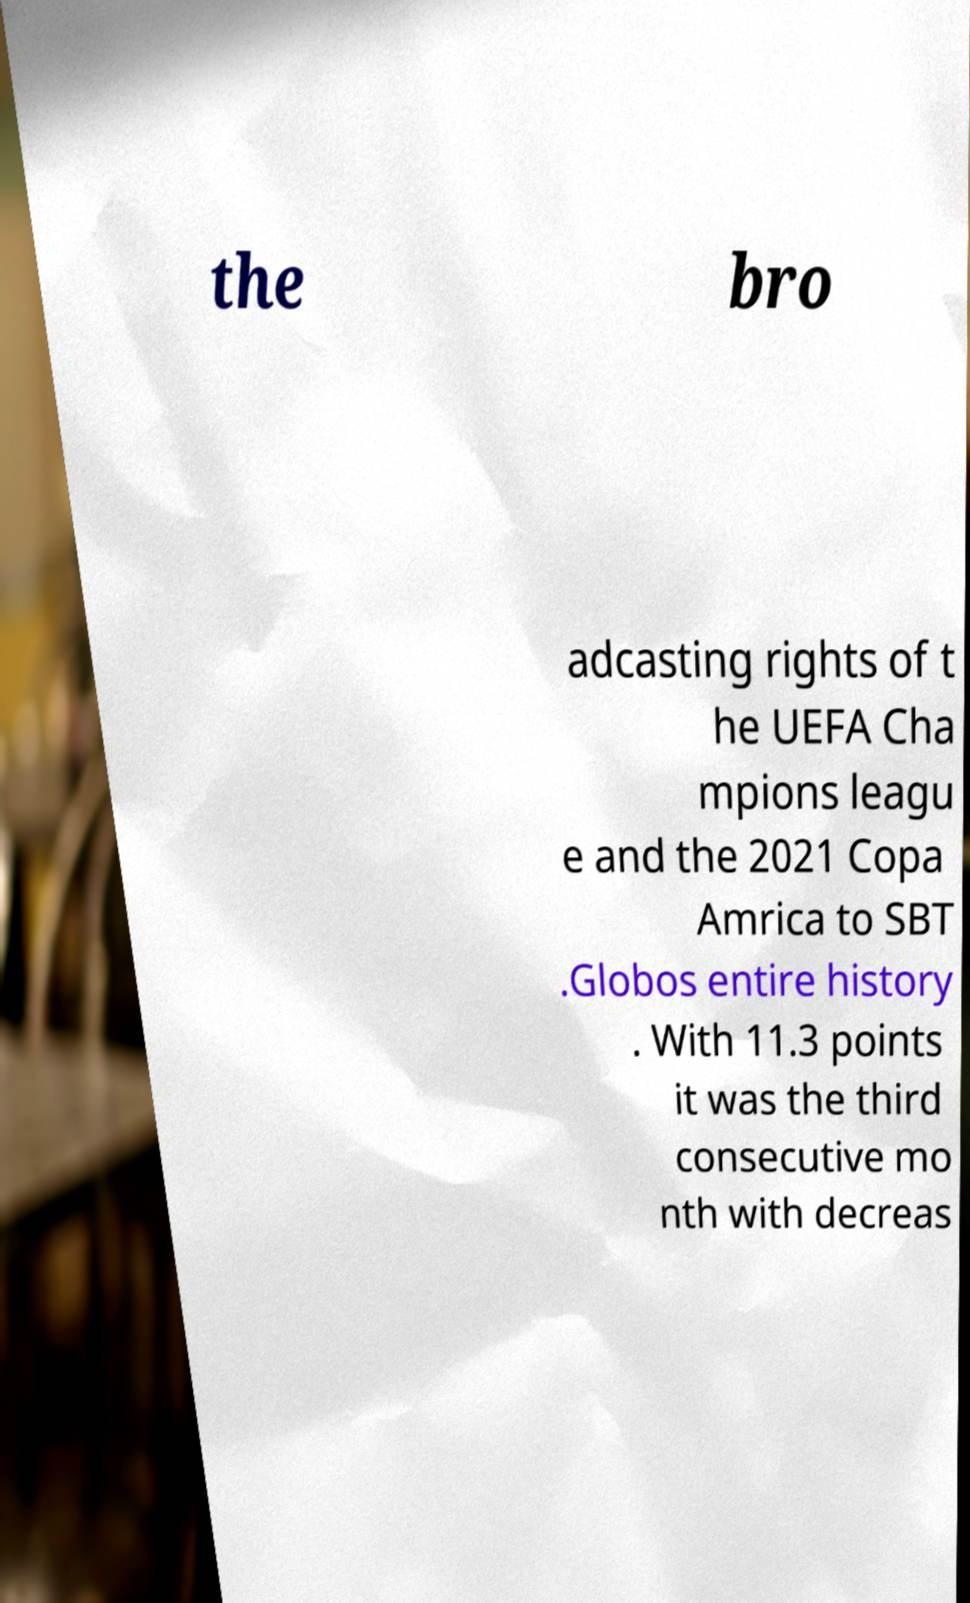Please read and relay the text visible in this image. What does it say? the bro adcasting rights of t he UEFA Cha mpions leagu e and the 2021 Copa Amrica to SBT .Globos entire history . With 11.3 points it was the third consecutive mo nth with decreas 